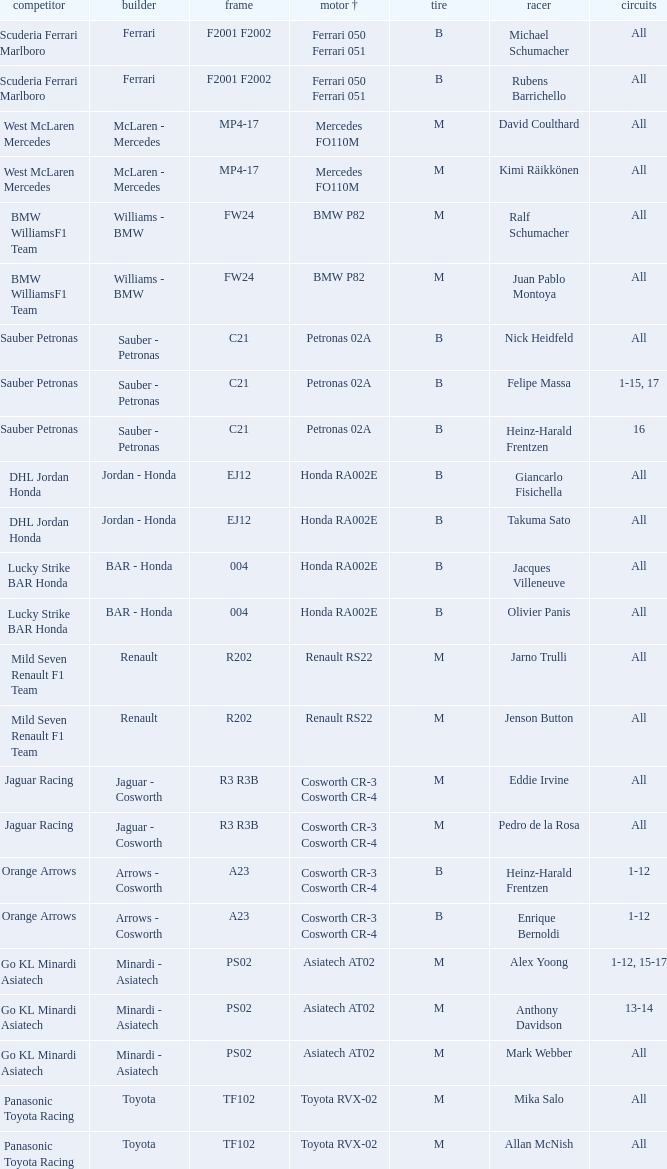Who is the entrant when the engine is bmw p82? BMW WilliamsF1 Team, BMW WilliamsF1 Team. 